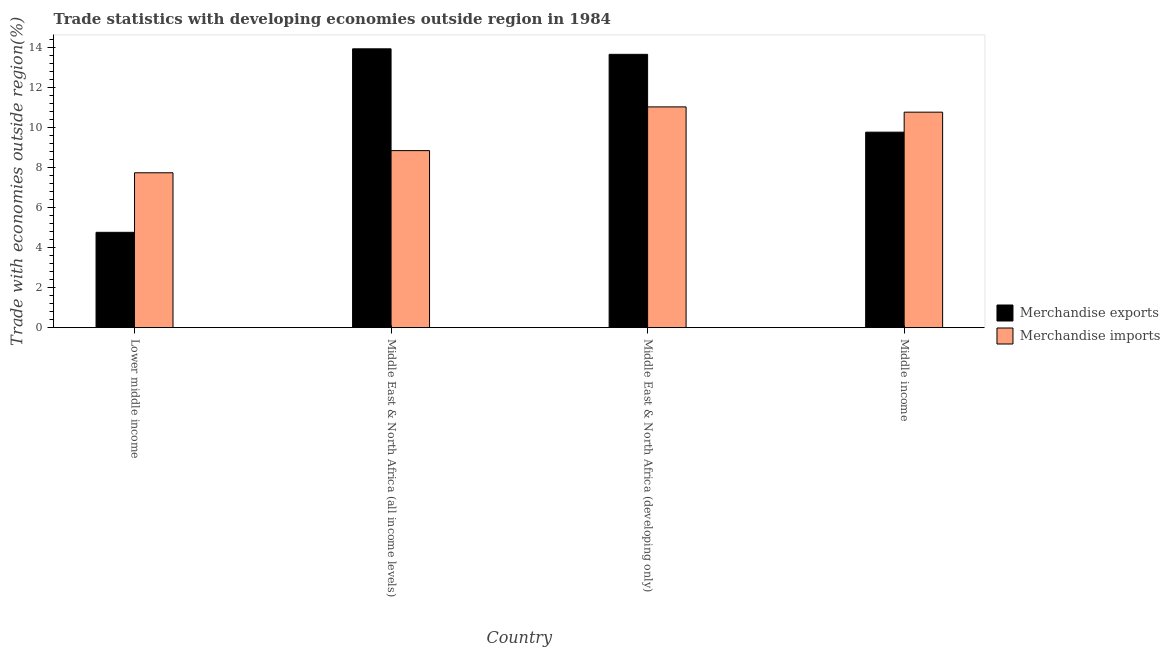Are the number of bars per tick equal to the number of legend labels?
Offer a terse response. Yes. Are the number of bars on each tick of the X-axis equal?
Provide a succinct answer. Yes. In how many cases, is the number of bars for a given country not equal to the number of legend labels?
Your response must be concise. 0. What is the merchandise exports in Middle East & North Africa (all income levels)?
Your answer should be very brief. 13.92. Across all countries, what is the maximum merchandise exports?
Keep it short and to the point. 13.92. Across all countries, what is the minimum merchandise imports?
Ensure brevity in your answer.  7.73. In which country was the merchandise imports maximum?
Your answer should be very brief. Middle East & North Africa (developing only). In which country was the merchandise exports minimum?
Offer a very short reply. Lower middle income. What is the total merchandise exports in the graph?
Your answer should be very brief. 42.09. What is the difference between the merchandise imports in Lower middle income and that in Middle East & North Africa (all income levels)?
Provide a succinct answer. -1.11. What is the difference between the merchandise imports in Lower middle income and the merchandise exports in Middle East & North Africa (all income levels)?
Your answer should be compact. -6.19. What is the average merchandise exports per country?
Your answer should be compact. 10.52. What is the difference between the merchandise imports and merchandise exports in Lower middle income?
Your response must be concise. 2.97. In how many countries, is the merchandise exports greater than 8.4 %?
Keep it short and to the point. 3. What is the ratio of the merchandise exports in Middle East & North Africa (all income levels) to that in Middle East & North Africa (developing only)?
Provide a short and direct response. 1.02. Is the difference between the merchandise exports in Lower middle income and Middle East & North Africa (developing only) greater than the difference between the merchandise imports in Lower middle income and Middle East & North Africa (developing only)?
Your answer should be compact. No. What is the difference between the highest and the second highest merchandise exports?
Keep it short and to the point. 0.28. What is the difference between the highest and the lowest merchandise exports?
Provide a succinct answer. 9.16. What does the 2nd bar from the right in Middle East & North Africa (all income levels) represents?
Provide a succinct answer. Merchandise exports. What is the difference between two consecutive major ticks on the Y-axis?
Offer a terse response. 2. Are the values on the major ticks of Y-axis written in scientific E-notation?
Make the answer very short. No. Does the graph contain any zero values?
Provide a short and direct response. No. Does the graph contain grids?
Your answer should be compact. No. Where does the legend appear in the graph?
Provide a short and direct response. Center right. How many legend labels are there?
Keep it short and to the point. 2. What is the title of the graph?
Your answer should be very brief. Trade statistics with developing economies outside region in 1984. Does "RDB concessional" appear as one of the legend labels in the graph?
Ensure brevity in your answer.  No. What is the label or title of the Y-axis?
Give a very brief answer. Trade with economies outside region(%). What is the Trade with economies outside region(%) of Merchandise exports in Lower middle income?
Your response must be concise. 4.76. What is the Trade with economies outside region(%) in Merchandise imports in Lower middle income?
Keep it short and to the point. 7.73. What is the Trade with economies outside region(%) in Merchandise exports in Middle East & North Africa (all income levels)?
Ensure brevity in your answer.  13.92. What is the Trade with economies outside region(%) in Merchandise imports in Middle East & North Africa (all income levels)?
Provide a succinct answer. 8.84. What is the Trade with economies outside region(%) in Merchandise exports in Middle East & North Africa (developing only)?
Your answer should be compact. 13.65. What is the Trade with economies outside region(%) in Merchandise imports in Middle East & North Africa (developing only)?
Provide a short and direct response. 11.02. What is the Trade with economies outside region(%) of Merchandise exports in Middle income?
Provide a short and direct response. 9.76. What is the Trade with economies outside region(%) of Merchandise imports in Middle income?
Provide a succinct answer. 10.76. Across all countries, what is the maximum Trade with economies outside region(%) in Merchandise exports?
Provide a short and direct response. 13.92. Across all countries, what is the maximum Trade with economies outside region(%) in Merchandise imports?
Make the answer very short. 11.02. Across all countries, what is the minimum Trade with economies outside region(%) in Merchandise exports?
Your answer should be compact. 4.76. Across all countries, what is the minimum Trade with economies outside region(%) in Merchandise imports?
Your answer should be compact. 7.73. What is the total Trade with economies outside region(%) in Merchandise exports in the graph?
Give a very brief answer. 42.09. What is the total Trade with economies outside region(%) in Merchandise imports in the graph?
Your answer should be very brief. 38.36. What is the difference between the Trade with economies outside region(%) of Merchandise exports in Lower middle income and that in Middle East & North Africa (all income levels)?
Offer a terse response. -9.16. What is the difference between the Trade with economies outside region(%) in Merchandise imports in Lower middle income and that in Middle East & North Africa (all income levels)?
Offer a terse response. -1.11. What is the difference between the Trade with economies outside region(%) of Merchandise exports in Lower middle income and that in Middle East & North Africa (developing only)?
Ensure brevity in your answer.  -8.89. What is the difference between the Trade with economies outside region(%) of Merchandise imports in Lower middle income and that in Middle East & North Africa (developing only)?
Ensure brevity in your answer.  -3.29. What is the difference between the Trade with economies outside region(%) in Merchandise exports in Lower middle income and that in Middle income?
Ensure brevity in your answer.  -5. What is the difference between the Trade with economies outside region(%) in Merchandise imports in Lower middle income and that in Middle income?
Make the answer very short. -3.03. What is the difference between the Trade with economies outside region(%) in Merchandise exports in Middle East & North Africa (all income levels) and that in Middle East & North Africa (developing only)?
Keep it short and to the point. 0.28. What is the difference between the Trade with economies outside region(%) of Merchandise imports in Middle East & North Africa (all income levels) and that in Middle East & North Africa (developing only)?
Your answer should be compact. -2.18. What is the difference between the Trade with economies outside region(%) of Merchandise exports in Middle East & North Africa (all income levels) and that in Middle income?
Provide a succinct answer. 4.16. What is the difference between the Trade with economies outside region(%) of Merchandise imports in Middle East & North Africa (all income levels) and that in Middle income?
Offer a terse response. -1.92. What is the difference between the Trade with economies outside region(%) of Merchandise exports in Middle East & North Africa (developing only) and that in Middle income?
Your answer should be very brief. 3.89. What is the difference between the Trade with economies outside region(%) of Merchandise imports in Middle East & North Africa (developing only) and that in Middle income?
Your response must be concise. 0.26. What is the difference between the Trade with economies outside region(%) in Merchandise exports in Lower middle income and the Trade with economies outside region(%) in Merchandise imports in Middle East & North Africa (all income levels)?
Your answer should be very brief. -4.08. What is the difference between the Trade with economies outside region(%) of Merchandise exports in Lower middle income and the Trade with economies outside region(%) of Merchandise imports in Middle East & North Africa (developing only)?
Provide a short and direct response. -6.26. What is the difference between the Trade with economies outside region(%) in Merchandise exports in Lower middle income and the Trade with economies outside region(%) in Merchandise imports in Middle income?
Give a very brief answer. -6. What is the difference between the Trade with economies outside region(%) of Merchandise exports in Middle East & North Africa (all income levels) and the Trade with economies outside region(%) of Merchandise imports in Middle East & North Africa (developing only)?
Offer a terse response. 2.9. What is the difference between the Trade with economies outside region(%) of Merchandise exports in Middle East & North Africa (all income levels) and the Trade with economies outside region(%) of Merchandise imports in Middle income?
Provide a short and direct response. 3.16. What is the difference between the Trade with economies outside region(%) of Merchandise exports in Middle East & North Africa (developing only) and the Trade with economies outside region(%) of Merchandise imports in Middle income?
Give a very brief answer. 2.89. What is the average Trade with economies outside region(%) in Merchandise exports per country?
Your response must be concise. 10.52. What is the average Trade with economies outside region(%) of Merchandise imports per country?
Give a very brief answer. 9.59. What is the difference between the Trade with economies outside region(%) in Merchandise exports and Trade with economies outside region(%) in Merchandise imports in Lower middle income?
Your answer should be compact. -2.97. What is the difference between the Trade with economies outside region(%) of Merchandise exports and Trade with economies outside region(%) of Merchandise imports in Middle East & North Africa (all income levels)?
Make the answer very short. 5.08. What is the difference between the Trade with economies outside region(%) of Merchandise exports and Trade with economies outside region(%) of Merchandise imports in Middle East & North Africa (developing only)?
Keep it short and to the point. 2.62. What is the difference between the Trade with economies outside region(%) of Merchandise exports and Trade with economies outside region(%) of Merchandise imports in Middle income?
Make the answer very short. -1. What is the ratio of the Trade with economies outside region(%) of Merchandise exports in Lower middle income to that in Middle East & North Africa (all income levels)?
Ensure brevity in your answer.  0.34. What is the ratio of the Trade with economies outside region(%) in Merchandise imports in Lower middle income to that in Middle East & North Africa (all income levels)?
Give a very brief answer. 0.87. What is the ratio of the Trade with economies outside region(%) of Merchandise exports in Lower middle income to that in Middle East & North Africa (developing only)?
Give a very brief answer. 0.35. What is the ratio of the Trade with economies outside region(%) of Merchandise imports in Lower middle income to that in Middle East & North Africa (developing only)?
Keep it short and to the point. 0.7. What is the ratio of the Trade with economies outside region(%) of Merchandise exports in Lower middle income to that in Middle income?
Your answer should be very brief. 0.49. What is the ratio of the Trade with economies outside region(%) in Merchandise imports in Lower middle income to that in Middle income?
Make the answer very short. 0.72. What is the ratio of the Trade with economies outside region(%) of Merchandise exports in Middle East & North Africa (all income levels) to that in Middle East & North Africa (developing only)?
Keep it short and to the point. 1.02. What is the ratio of the Trade with economies outside region(%) of Merchandise imports in Middle East & North Africa (all income levels) to that in Middle East & North Africa (developing only)?
Provide a succinct answer. 0.8. What is the ratio of the Trade with economies outside region(%) of Merchandise exports in Middle East & North Africa (all income levels) to that in Middle income?
Your response must be concise. 1.43. What is the ratio of the Trade with economies outside region(%) in Merchandise imports in Middle East & North Africa (all income levels) to that in Middle income?
Ensure brevity in your answer.  0.82. What is the ratio of the Trade with economies outside region(%) in Merchandise exports in Middle East & North Africa (developing only) to that in Middle income?
Your answer should be compact. 1.4. What is the ratio of the Trade with economies outside region(%) of Merchandise imports in Middle East & North Africa (developing only) to that in Middle income?
Keep it short and to the point. 1.02. What is the difference between the highest and the second highest Trade with economies outside region(%) of Merchandise exports?
Make the answer very short. 0.28. What is the difference between the highest and the second highest Trade with economies outside region(%) of Merchandise imports?
Your answer should be very brief. 0.26. What is the difference between the highest and the lowest Trade with economies outside region(%) in Merchandise exports?
Your answer should be very brief. 9.16. What is the difference between the highest and the lowest Trade with economies outside region(%) in Merchandise imports?
Provide a succinct answer. 3.29. 